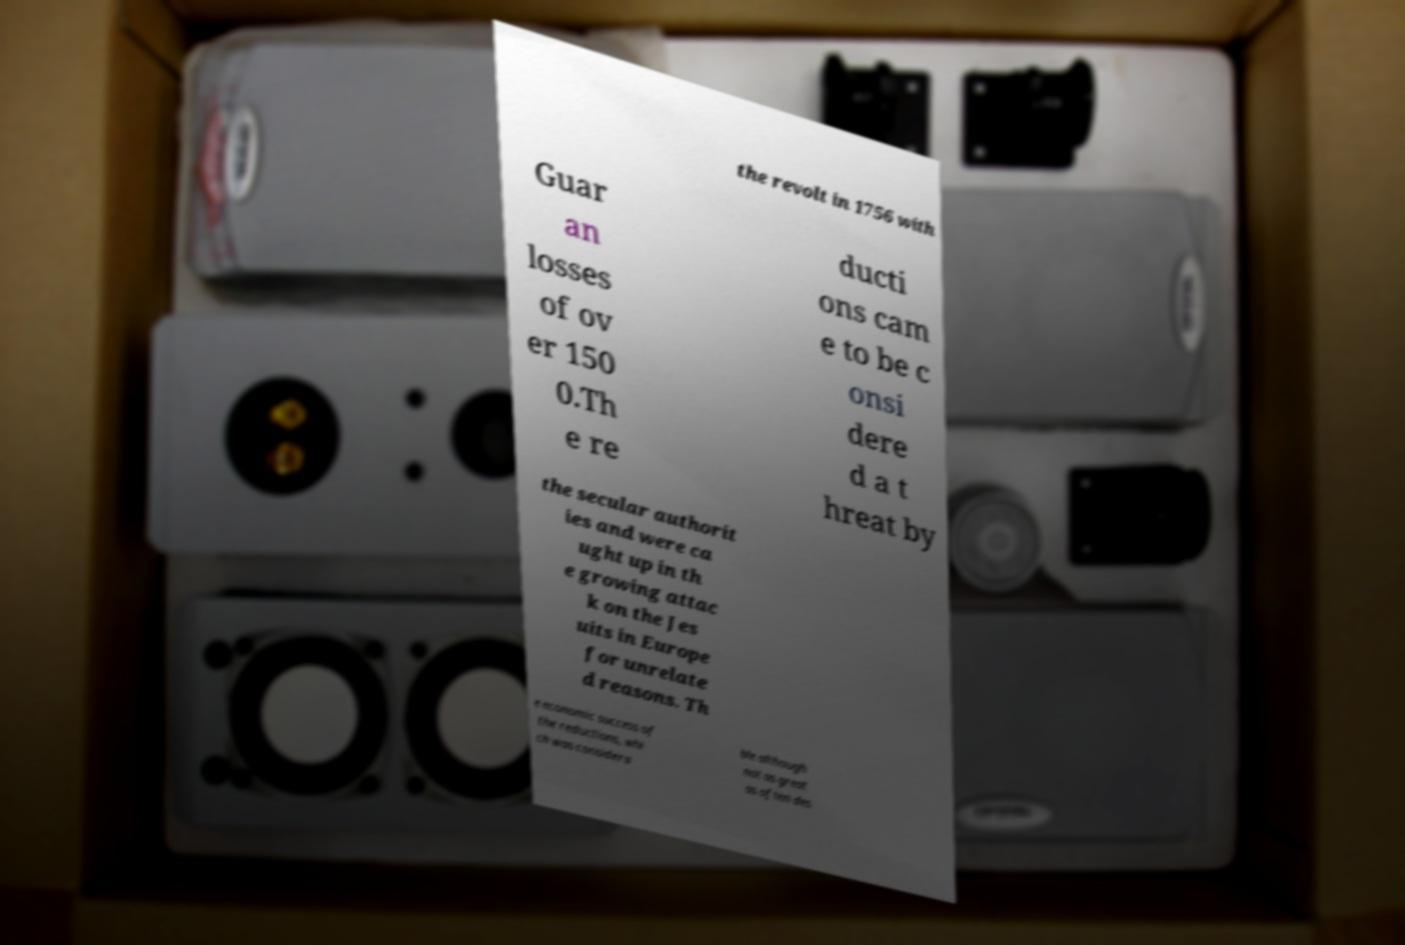Could you extract and type out the text from this image? the revolt in 1756 with Guar an losses of ov er 150 0.Th e re ducti ons cam e to be c onsi dere d a t hreat by the secular authorit ies and were ca ught up in th e growing attac k on the Jes uits in Europe for unrelate d reasons. Th e economic success of the reductions, whi ch was considera ble although not as great as often des 